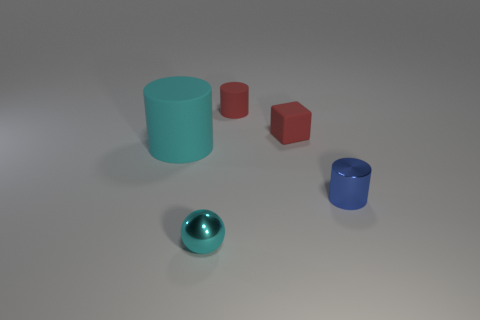Add 1 large cyan cubes. How many objects exist? 6 Subtract all cubes. How many objects are left? 4 Add 2 big blocks. How many big blocks exist? 2 Subtract 0 yellow blocks. How many objects are left? 5 Subtract all cyan cylinders. Subtract all brown things. How many objects are left? 4 Add 5 cyan spheres. How many cyan spheres are left? 6 